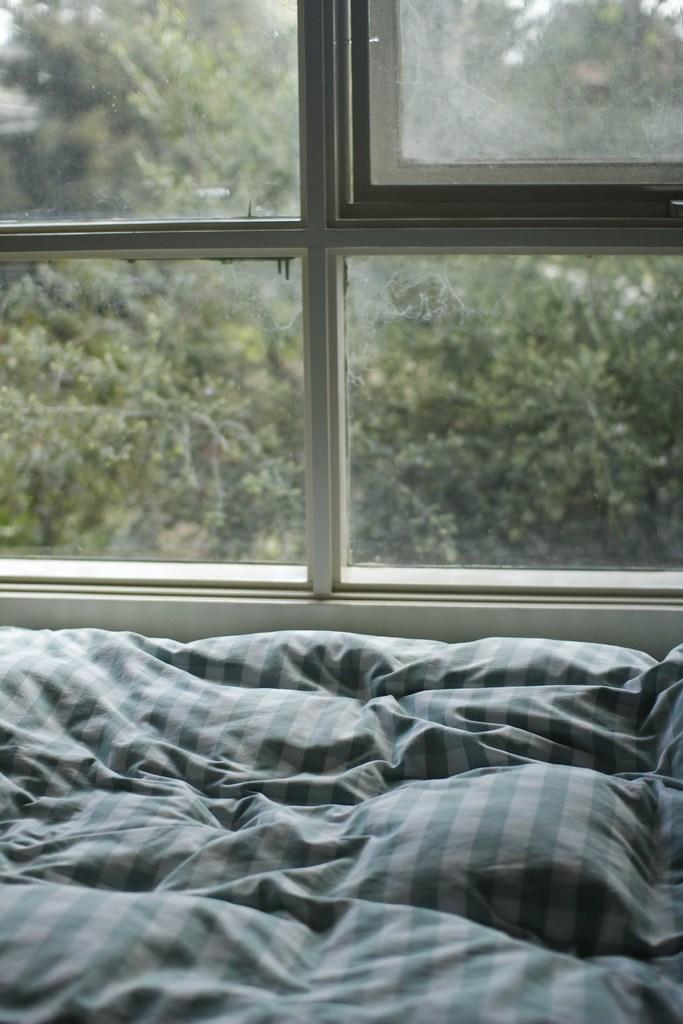What type of furniture is present in the image? There is a bed in the image. What can be seen through the window in the image? There is a glass window in the image. What type of vegetation is visible in the background of the image? There are green color trees in the background of the image. Can you see a hen swimming in the background of the image? There is no hen or swimming activity present in the image. What type of border is visible around the trees in the background? There is no border visible around the trees in the background; only the trees themselves are present. 